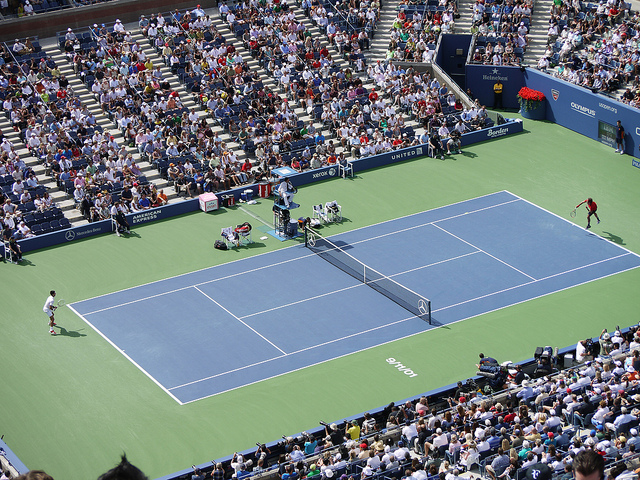Read and extract the text from this image. UNITED F 